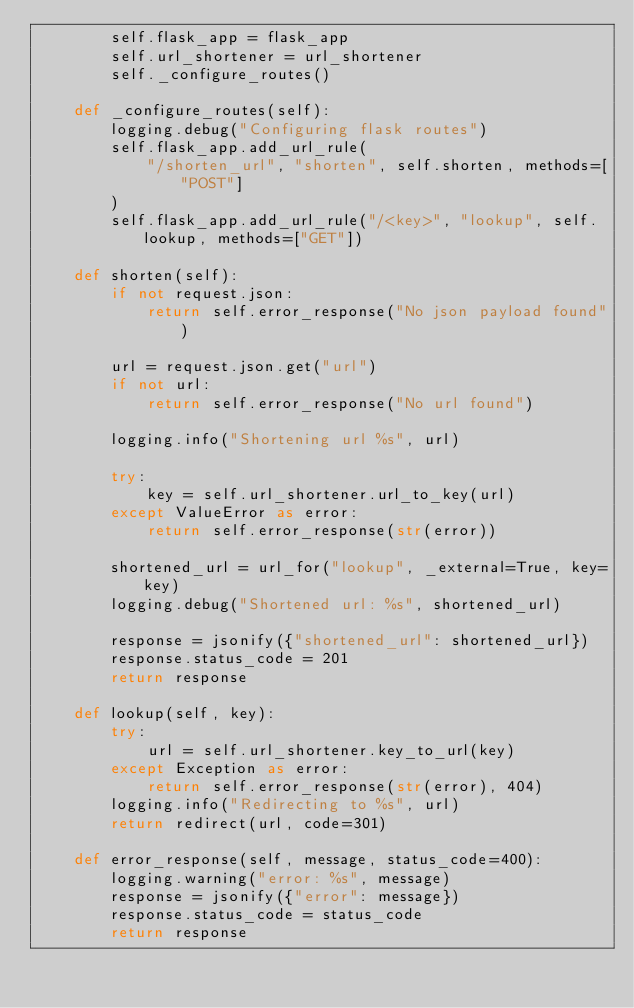Convert code to text. <code><loc_0><loc_0><loc_500><loc_500><_Python_>        self.flask_app = flask_app
        self.url_shortener = url_shortener
        self._configure_routes()

    def _configure_routes(self):
        logging.debug("Configuring flask routes")
        self.flask_app.add_url_rule(
            "/shorten_url", "shorten", self.shorten, methods=["POST"]
        )
        self.flask_app.add_url_rule("/<key>", "lookup", self.lookup, methods=["GET"])

    def shorten(self):
        if not request.json:
            return self.error_response("No json payload found")

        url = request.json.get("url")
        if not url:
            return self.error_response("No url found")

        logging.info("Shortening url %s", url)

        try:
            key = self.url_shortener.url_to_key(url)
        except ValueError as error:
            return self.error_response(str(error))

        shortened_url = url_for("lookup", _external=True, key=key)
        logging.debug("Shortened url: %s", shortened_url)

        response = jsonify({"shortened_url": shortened_url})
        response.status_code = 201
        return response

    def lookup(self, key):
        try:
            url = self.url_shortener.key_to_url(key)
        except Exception as error:
            return self.error_response(str(error), 404)
        logging.info("Redirecting to %s", url)
        return redirect(url, code=301)

    def error_response(self, message, status_code=400):
        logging.warning("error: %s", message)
        response = jsonify({"error": message})
        response.status_code = status_code
        return response
</code> 